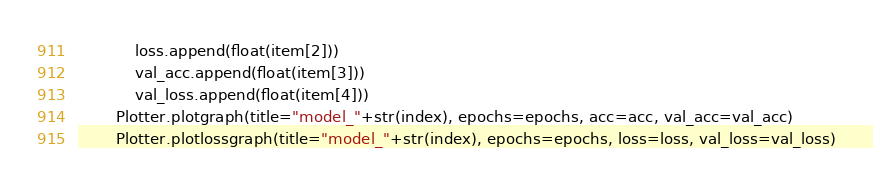Convert code to text. <code><loc_0><loc_0><loc_500><loc_500><_Python_>            loss.append(float(item[2]))
            val_acc.append(float(item[3]))
            val_loss.append(float(item[4]))
        Plotter.plotgraph(title="model_"+str(index), epochs=epochs, acc=acc, val_acc=val_acc)
        Plotter.plotlossgraph(title="model_"+str(index), epochs=epochs, loss=loss, val_loss=val_loss)

</code> 